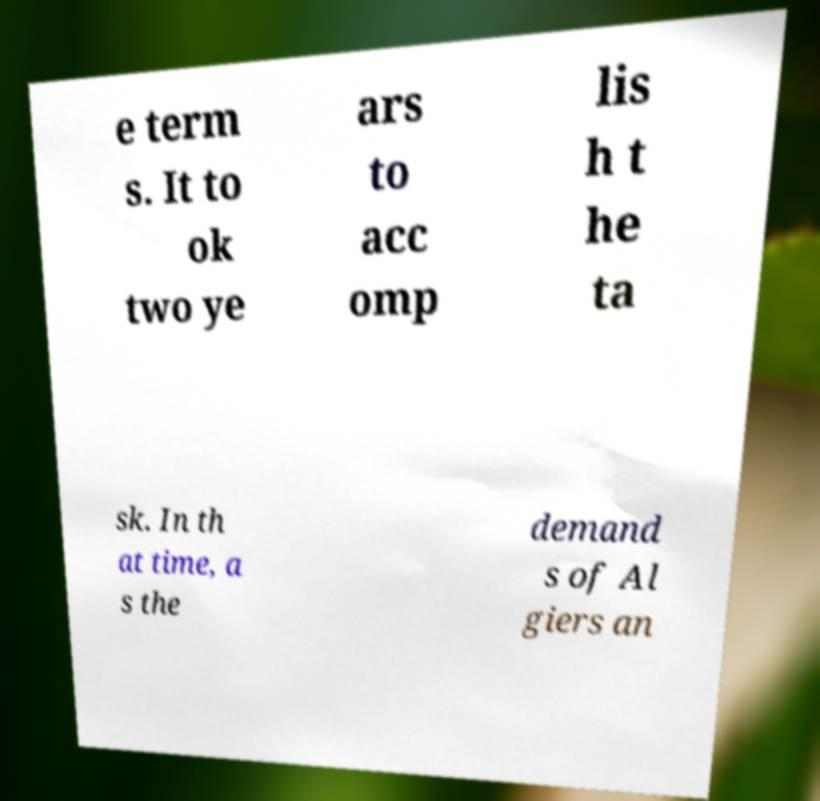Please read and relay the text visible in this image. What does it say? e term s. It to ok two ye ars to acc omp lis h t he ta sk. In th at time, a s the demand s of Al giers an 